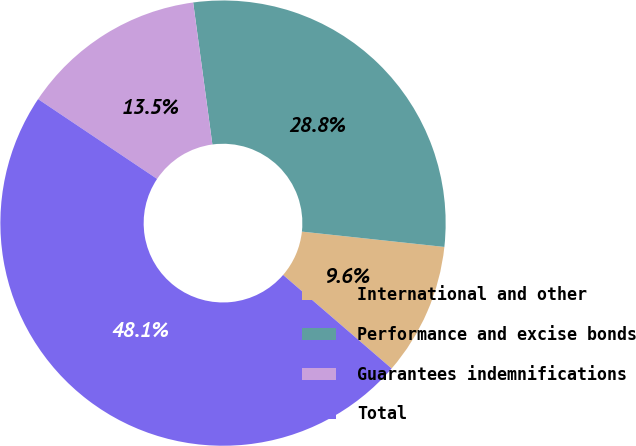Convert chart to OTSL. <chart><loc_0><loc_0><loc_500><loc_500><pie_chart><fcel>International and other<fcel>Performance and excise bonds<fcel>Guarantees indemnifications<fcel>Total<nl><fcel>9.62%<fcel>28.85%<fcel>13.46%<fcel>48.08%<nl></chart> 